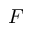<formula> <loc_0><loc_0><loc_500><loc_500>F</formula> 